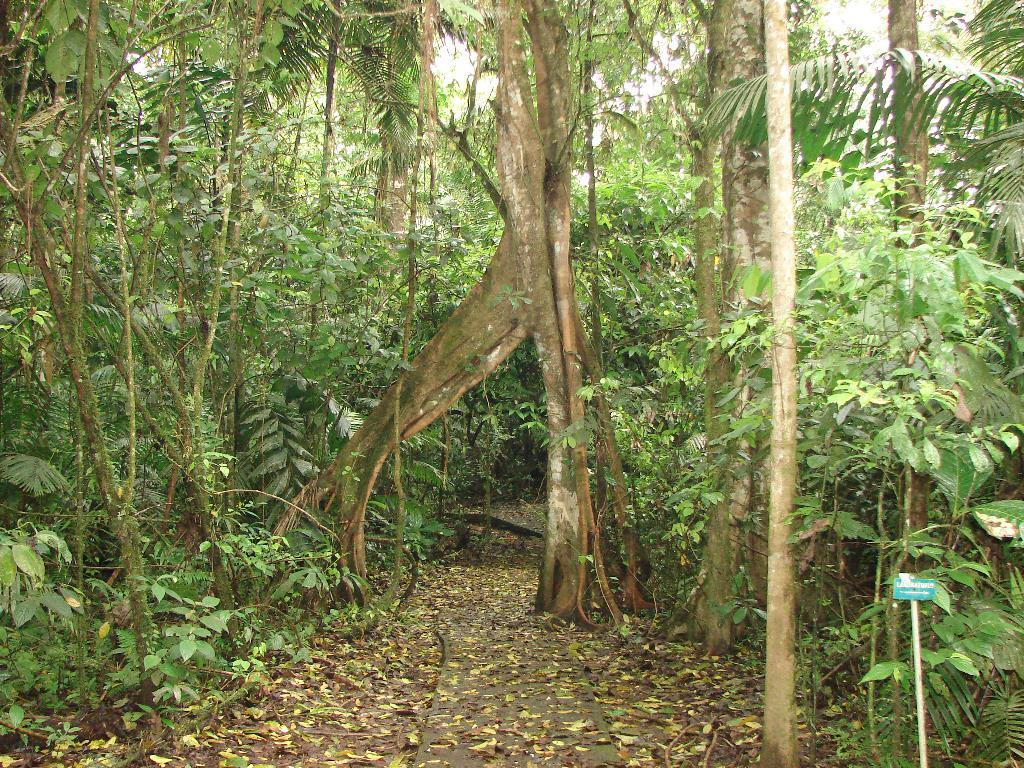What type of vegetation is present in the image? There are green trees in the image. Where are the leaves located in the image? The leaves are at the bottom of the image. What type of advice is the minister giving to the kitty in the cellar in the image? There is no minister, kitty, or cellar present in the image. 